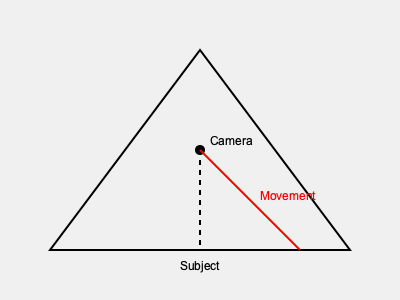In the iconic scene where Damiel observes Berlin from above, Wenders employs a specific camera movement that enhances the ethereal quality of the angel's perspective. Based on the diagram, which represents the camera's position and movement, what technique does Wenders use to achieve this effect? To answer this question, let's analyze the diagram and relate it to Wenders' cinematography in "Wings of Desire":

1. The triangle in the diagram represents the field of view of the camera.
2. The circle at the apex of the triangle indicates the camera's initial position, which is elevated above the subject (represented at the base of the triangle).
3. The red curved line shows the camera's movement from its initial high position down towards the subject.
4. This movement is smooth and arc-like, suggesting a fluid transition from a high angle to a lower angle.

Given these observations, we can deduce that Wenders is using a crane shot or a sweeping aerial shot that gradually descends. This technique is characteristic of how he portrays the angel's perspective in the film, creating a sense of weightlessness and omniscience that slowly gives way to a more grounded, human point of view.

The gradual descent mimics the angel's contemplation of the human world and his eventual desire to experience it directly. This camera movement serves multiple purposes:

1. It establishes the angel's initial detachment from the earthly realm.
2. It creates a visual metaphor for the transition between heavenly and earthly perspectives.
3. It immerses the viewer in the angel's experience, enhancing the film's philosophical exploration of human existence.

This technique is a prime example of Wenders' masterful use of camera movement to convey complex themes and emotions in "Wings of Desire."
Answer: Descending crane shot 